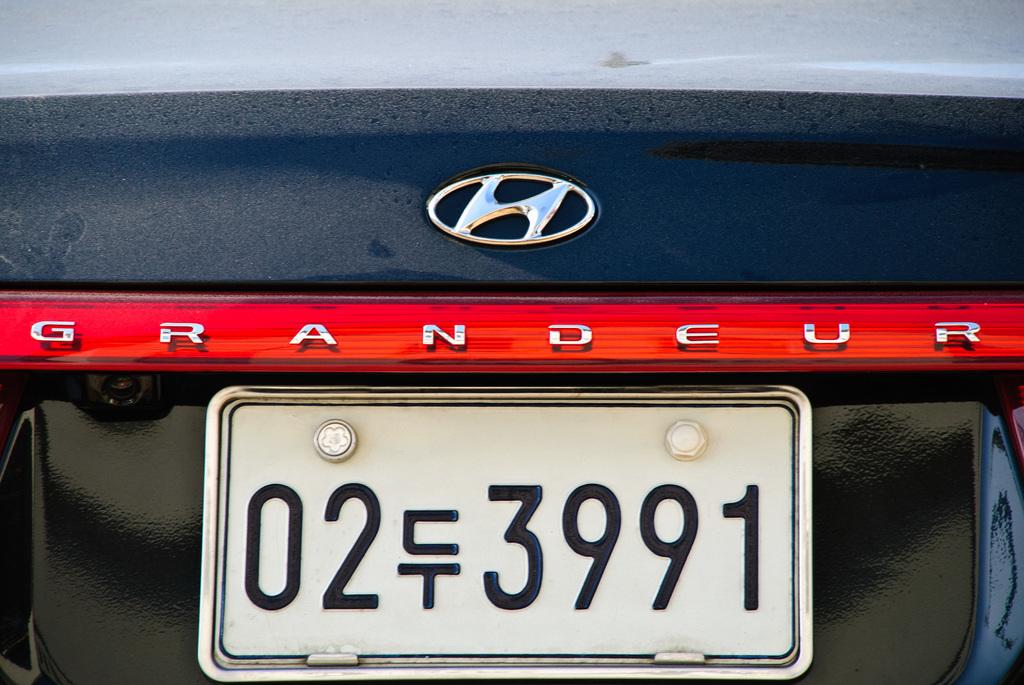What is the license plate number?
Ensure brevity in your answer.  02 3991. What brand of car is this?
Provide a succinct answer. Hyundai. 